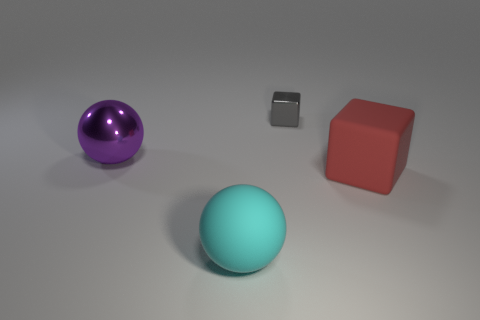Subtract 1 balls. How many balls are left? 1 Add 3 small blue cylinders. How many objects exist? 7 Subtract all gray cubes. How many cubes are left? 1 Subtract all purple cubes. How many cyan spheres are left? 1 Subtract all small cubes. Subtract all metal blocks. How many objects are left? 2 Add 2 red objects. How many red objects are left? 3 Add 4 small yellow objects. How many small yellow objects exist? 4 Subtract 1 cyan spheres. How many objects are left? 3 Subtract all yellow spheres. Subtract all gray cylinders. How many spheres are left? 2 